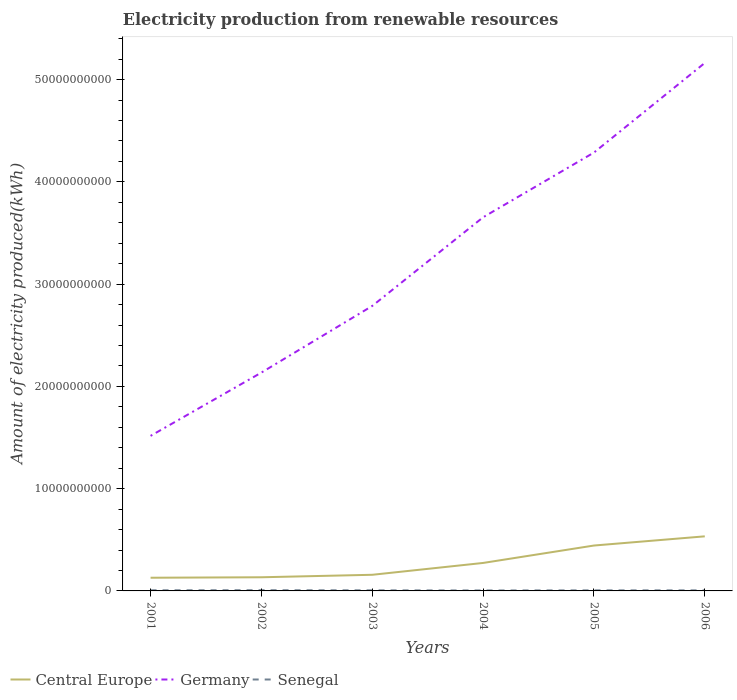Across all years, what is the maximum amount of electricity produced in Central Europe?
Keep it short and to the point. 1.29e+09. What is the difference between the highest and the second highest amount of electricity produced in Senegal?
Your answer should be very brief. 2.50e+07. What is the difference between the highest and the lowest amount of electricity produced in Senegal?
Provide a short and direct response. 2. What is the difference between two consecutive major ticks on the Y-axis?
Provide a succinct answer. 1.00e+1. Are the values on the major ticks of Y-axis written in scientific E-notation?
Offer a terse response. No. Does the graph contain any zero values?
Your response must be concise. No. Does the graph contain grids?
Provide a short and direct response. No. How many legend labels are there?
Your response must be concise. 3. What is the title of the graph?
Give a very brief answer. Electricity production from renewable resources. What is the label or title of the X-axis?
Give a very brief answer. Years. What is the label or title of the Y-axis?
Ensure brevity in your answer.  Amount of electricity produced(kWh). What is the Amount of electricity produced(kWh) of Central Europe in 2001?
Give a very brief answer. 1.29e+09. What is the Amount of electricity produced(kWh) of Germany in 2001?
Make the answer very short. 1.52e+1. What is the Amount of electricity produced(kWh) in Senegal in 2001?
Offer a terse response. 6.20e+07. What is the Amount of electricity produced(kWh) in Central Europe in 2002?
Your answer should be compact. 1.34e+09. What is the Amount of electricity produced(kWh) in Germany in 2002?
Your answer should be very brief. 2.14e+1. What is the Amount of electricity produced(kWh) of Senegal in 2002?
Give a very brief answer. 7.00e+07. What is the Amount of electricity produced(kWh) in Central Europe in 2003?
Your answer should be compact. 1.58e+09. What is the Amount of electricity produced(kWh) of Germany in 2003?
Your answer should be compact. 2.79e+1. What is the Amount of electricity produced(kWh) in Senegal in 2003?
Ensure brevity in your answer.  5.70e+07. What is the Amount of electricity produced(kWh) of Central Europe in 2004?
Give a very brief answer. 2.74e+09. What is the Amount of electricity produced(kWh) in Germany in 2004?
Make the answer very short. 3.65e+1. What is the Amount of electricity produced(kWh) of Senegal in 2004?
Offer a terse response. 4.50e+07. What is the Amount of electricity produced(kWh) of Central Europe in 2005?
Give a very brief answer. 4.44e+09. What is the Amount of electricity produced(kWh) in Germany in 2005?
Offer a very short reply. 4.29e+1. What is the Amount of electricity produced(kWh) in Senegal in 2005?
Provide a short and direct response. 5.50e+07. What is the Amount of electricity produced(kWh) of Central Europe in 2006?
Offer a terse response. 5.34e+09. What is the Amount of electricity produced(kWh) of Germany in 2006?
Offer a terse response. 5.16e+1. What is the Amount of electricity produced(kWh) of Senegal in 2006?
Keep it short and to the point. 5.50e+07. Across all years, what is the maximum Amount of electricity produced(kWh) of Central Europe?
Offer a very short reply. 5.34e+09. Across all years, what is the maximum Amount of electricity produced(kWh) of Germany?
Your answer should be compact. 5.16e+1. Across all years, what is the maximum Amount of electricity produced(kWh) of Senegal?
Your answer should be compact. 7.00e+07. Across all years, what is the minimum Amount of electricity produced(kWh) in Central Europe?
Give a very brief answer. 1.29e+09. Across all years, what is the minimum Amount of electricity produced(kWh) in Germany?
Your answer should be very brief. 1.52e+1. Across all years, what is the minimum Amount of electricity produced(kWh) in Senegal?
Ensure brevity in your answer.  4.50e+07. What is the total Amount of electricity produced(kWh) of Central Europe in the graph?
Your response must be concise. 1.67e+1. What is the total Amount of electricity produced(kWh) in Germany in the graph?
Your response must be concise. 1.95e+11. What is the total Amount of electricity produced(kWh) of Senegal in the graph?
Your answer should be very brief. 3.44e+08. What is the difference between the Amount of electricity produced(kWh) in Central Europe in 2001 and that in 2002?
Make the answer very short. -4.50e+07. What is the difference between the Amount of electricity produced(kWh) in Germany in 2001 and that in 2002?
Your answer should be compact. -6.19e+09. What is the difference between the Amount of electricity produced(kWh) in Senegal in 2001 and that in 2002?
Offer a terse response. -8.00e+06. What is the difference between the Amount of electricity produced(kWh) of Central Europe in 2001 and that in 2003?
Offer a very short reply. -2.88e+08. What is the difference between the Amount of electricity produced(kWh) in Germany in 2001 and that in 2003?
Keep it short and to the point. -1.27e+1. What is the difference between the Amount of electricity produced(kWh) of Central Europe in 2001 and that in 2004?
Offer a terse response. -1.45e+09. What is the difference between the Amount of electricity produced(kWh) of Germany in 2001 and that in 2004?
Your answer should be compact. -2.14e+1. What is the difference between the Amount of electricity produced(kWh) of Senegal in 2001 and that in 2004?
Give a very brief answer. 1.70e+07. What is the difference between the Amount of electricity produced(kWh) of Central Europe in 2001 and that in 2005?
Make the answer very short. -3.15e+09. What is the difference between the Amount of electricity produced(kWh) in Germany in 2001 and that in 2005?
Give a very brief answer. -2.77e+1. What is the difference between the Amount of electricity produced(kWh) in Senegal in 2001 and that in 2005?
Make the answer very short. 7.00e+06. What is the difference between the Amount of electricity produced(kWh) in Central Europe in 2001 and that in 2006?
Offer a very short reply. -4.05e+09. What is the difference between the Amount of electricity produced(kWh) in Germany in 2001 and that in 2006?
Your response must be concise. -3.65e+1. What is the difference between the Amount of electricity produced(kWh) of Central Europe in 2002 and that in 2003?
Your response must be concise. -2.43e+08. What is the difference between the Amount of electricity produced(kWh) of Germany in 2002 and that in 2003?
Ensure brevity in your answer.  -6.52e+09. What is the difference between the Amount of electricity produced(kWh) of Senegal in 2002 and that in 2003?
Your answer should be very brief. 1.30e+07. What is the difference between the Amount of electricity produced(kWh) in Central Europe in 2002 and that in 2004?
Provide a short and direct response. -1.40e+09. What is the difference between the Amount of electricity produced(kWh) in Germany in 2002 and that in 2004?
Your answer should be compact. -1.52e+1. What is the difference between the Amount of electricity produced(kWh) in Senegal in 2002 and that in 2004?
Keep it short and to the point. 2.50e+07. What is the difference between the Amount of electricity produced(kWh) of Central Europe in 2002 and that in 2005?
Your answer should be very brief. -3.10e+09. What is the difference between the Amount of electricity produced(kWh) in Germany in 2002 and that in 2005?
Your answer should be very brief. -2.15e+1. What is the difference between the Amount of electricity produced(kWh) in Senegal in 2002 and that in 2005?
Keep it short and to the point. 1.50e+07. What is the difference between the Amount of electricity produced(kWh) of Central Europe in 2002 and that in 2006?
Ensure brevity in your answer.  -4.00e+09. What is the difference between the Amount of electricity produced(kWh) of Germany in 2002 and that in 2006?
Provide a succinct answer. -3.03e+1. What is the difference between the Amount of electricity produced(kWh) in Senegal in 2002 and that in 2006?
Give a very brief answer. 1.50e+07. What is the difference between the Amount of electricity produced(kWh) in Central Europe in 2003 and that in 2004?
Make the answer very short. -1.16e+09. What is the difference between the Amount of electricity produced(kWh) of Germany in 2003 and that in 2004?
Provide a short and direct response. -8.67e+09. What is the difference between the Amount of electricity produced(kWh) of Senegal in 2003 and that in 2004?
Keep it short and to the point. 1.20e+07. What is the difference between the Amount of electricity produced(kWh) of Central Europe in 2003 and that in 2005?
Your answer should be compact. -2.86e+09. What is the difference between the Amount of electricity produced(kWh) in Germany in 2003 and that in 2005?
Keep it short and to the point. -1.50e+1. What is the difference between the Amount of electricity produced(kWh) of Senegal in 2003 and that in 2005?
Offer a terse response. 2.00e+06. What is the difference between the Amount of electricity produced(kWh) in Central Europe in 2003 and that in 2006?
Your answer should be very brief. -3.76e+09. What is the difference between the Amount of electricity produced(kWh) in Germany in 2003 and that in 2006?
Provide a succinct answer. -2.38e+1. What is the difference between the Amount of electricity produced(kWh) of Senegal in 2003 and that in 2006?
Offer a very short reply. 2.00e+06. What is the difference between the Amount of electricity produced(kWh) in Central Europe in 2004 and that in 2005?
Your answer should be compact. -1.70e+09. What is the difference between the Amount of electricity produced(kWh) of Germany in 2004 and that in 2005?
Give a very brief answer. -6.33e+09. What is the difference between the Amount of electricity produced(kWh) of Senegal in 2004 and that in 2005?
Ensure brevity in your answer.  -1.00e+07. What is the difference between the Amount of electricity produced(kWh) in Central Europe in 2004 and that in 2006?
Your answer should be very brief. -2.60e+09. What is the difference between the Amount of electricity produced(kWh) in Germany in 2004 and that in 2006?
Your response must be concise. -1.51e+1. What is the difference between the Amount of electricity produced(kWh) of Senegal in 2004 and that in 2006?
Your answer should be very brief. -1.00e+07. What is the difference between the Amount of electricity produced(kWh) of Central Europe in 2005 and that in 2006?
Your answer should be very brief. -8.99e+08. What is the difference between the Amount of electricity produced(kWh) of Germany in 2005 and that in 2006?
Give a very brief answer. -8.76e+09. What is the difference between the Amount of electricity produced(kWh) in Central Europe in 2001 and the Amount of electricity produced(kWh) in Germany in 2002?
Provide a succinct answer. -2.01e+1. What is the difference between the Amount of electricity produced(kWh) in Central Europe in 2001 and the Amount of electricity produced(kWh) in Senegal in 2002?
Your answer should be compact. 1.22e+09. What is the difference between the Amount of electricity produced(kWh) of Germany in 2001 and the Amount of electricity produced(kWh) of Senegal in 2002?
Give a very brief answer. 1.51e+1. What is the difference between the Amount of electricity produced(kWh) of Central Europe in 2001 and the Amount of electricity produced(kWh) of Germany in 2003?
Your answer should be very brief. -2.66e+1. What is the difference between the Amount of electricity produced(kWh) in Central Europe in 2001 and the Amount of electricity produced(kWh) in Senegal in 2003?
Your answer should be very brief. 1.23e+09. What is the difference between the Amount of electricity produced(kWh) of Germany in 2001 and the Amount of electricity produced(kWh) of Senegal in 2003?
Offer a very short reply. 1.51e+1. What is the difference between the Amount of electricity produced(kWh) in Central Europe in 2001 and the Amount of electricity produced(kWh) in Germany in 2004?
Provide a short and direct response. -3.52e+1. What is the difference between the Amount of electricity produced(kWh) of Central Europe in 2001 and the Amount of electricity produced(kWh) of Senegal in 2004?
Your response must be concise. 1.24e+09. What is the difference between the Amount of electricity produced(kWh) of Germany in 2001 and the Amount of electricity produced(kWh) of Senegal in 2004?
Ensure brevity in your answer.  1.51e+1. What is the difference between the Amount of electricity produced(kWh) of Central Europe in 2001 and the Amount of electricity produced(kWh) of Germany in 2005?
Ensure brevity in your answer.  -4.16e+1. What is the difference between the Amount of electricity produced(kWh) of Central Europe in 2001 and the Amount of electricity produced(kWh) of Senegal in 2005?
Keep it short and to the point. 1.24e+09. What is the difference between the Amount of electricity produced(kWh) of Germany in 2001 and the Amount of electricity produced(kWh) of Senegal in 2005?
Your answer should be very brief. 1.51e+1. What is the difference between the Amount of electricity produced(kWh) of Central Europe in 2001 and the Amount of electricity produced(kWh) of Germany in 2006?
Keep it short and to the point. -5.03e+1. What is the difference between the Amount of electricity produced(kWh) in Central Europe in 2001 and the Amount of electricity produced(kWh) in Senegal in 2006?
Keep it short and to the point. 1.24e+09. What is the difference between the Amount of electricity produced(kWh) of Germany in 2001 and the Amount of electricity produced(kWh) of Senegal in 2006?
Offer a very short reply. 1.51e+1. What is the difference between the Amount of electricity produced(kWh) in Central Europe in 2002 and the Amount of electricity produced(kWh) in Germany in 2003?
Offer a very short reply. -2.65e+1. What is the difference between the Amount of electricity produced(kWh) of Central Europe in 2002 and the Amount of electricity produced(kWh) of Senegal in 2003?
Provide a short and direct response. 1.28e+09. What is the difference between the Amount of electricity produced(kWh) in Germany in 2002 and the Amount of electricity produced(kWh) in Senegal in 2003?
Keep it short and to the point. 2.13e+1. What is the difference between the Amount of electricity produced(kWh) of Central Europe in 2002 and the Amount of electricity produced(kWh) of Germany in 2004?
Your answer should be compact. -3.52e+1. What is the difference between the Amount of electricity produced(kWh) of Central Europe in 2002 and the Amount of electricity produced(kWh) of Senegal in 2004?
Provide a short and direct response. 1.29e+09. What is the difference between the Amount of electricity produced(kWh) of Germany in 2002 and the Amount of electricity produced(kWh) of Senegal in 2004?
Provide a short and direct response. 2.13e+1. What is the difference between the Amount of electricity produced(kWh) of Central Europe in 2002 and the Amount of electricity produced(kWh) of Germany in 2005?
Offer a terse response. -4.15e+1. What is the difference between the Amount of electricity produced(kWh) of Central Europe in 2002 and the Amount of electricity produced(kWh) of Senegal in 2005?
Make the answer very short. 1.28e+09. What is the difference between the Amount of electricity produced(kWh) of Germany in 2002 and the Amount of electricity produced(kWh) of Senegal in 2005?
Offer a very short reply. 2.13e+1. What is the difference between the Amount of electricity produced(kWh) of Central Europe in 2002 and the Amount of electricity produced(kWh) of Germany in 2006?
Keep it short and to the point. -5.03e+1. What is the difference between the Amount of electricity produced(kWh) of Central Europe in 2002 and the Amount of electricity produced(kWh) of Senegal in 2006?
Offer a very short reply. 1.28e+09. What is the difference between the Amount of electricity produced(kWh) in Germany in 2002 and the Amount of electricity produced(kWh) in Senegal in 2006?
Offer a very short reply. 2.13e+1. What is the difference between the Amount of electricity produced(kWh) in Central Europe in 2003 and the Amount of electricity produced(kWh) in Germany in 2004?
Make the answer very short. -3.50e+1. What is the difference between the Amount of electricity produced(kWh) in Central Europe in 2003 and the Amount of electricity produced(kWh) in Senegal in 2004?
Your answer should be very brief. 1.53e+09. What is the difference between the Amount of electricity produced(kWh) in Germany in 2003 and the Amount of electricity produced(kWh) in Senegal in 2004?
Keep it short and to the point. 2.78e+1. What is the difference between the Amount of electricity produced(kWh) in Central Europe in 2003 and the Amount of electricity produced(kWh) in Germany in 2005?
Offer a terse response. -4.13e+1. What is the difference between the Amount of electricity produced(kWh) of Central Europe in 2003 and the Amount of electricity produced(kWh) of Senegal in 2005?
Make the answer very short. 1.52e+09. What is the difference between the Amount of electricity produced(kWh) of Germany in 2003 and the Amount of electricity produced(kWh) of Senegal in 2005?
Give a very brief answer. 2.78e+1. What is the difference between the Amount of electricity produced(kWh) in Central Europe in 2003 and the Amount of electricity produced(kWh) in Germany in 2006?
Your answer should be very brief. -5.01e+1. What is the difference between the Amount of electricity produced(kWh) of Central Europe in 2003 and the Amount of electricity produced(kWh) of Senegal in 2006?
Give a very brief answer. 1.52e+09. What is the difference between the Amount of electricity produced(kWh) of Germany in 2003 and the Amount of electricity produced(kWh) of Senegal in 2006?
Give a very brief answer. 2.78e+1. What is the difference between the Amount of electricity produced(kWh) of Central Europe in 2004 and the Amount of electricity produced(kWh) of Germany in 2005?
Provide a short and direct response. -4.01e+1. What is the difference between the Amount of electricity produced(kWh) in Central Europe in 2004 and the Amount of electricity produced(kWh) in Senegal in 2005?
Your response must be concise. 2.68e+09. What is the difference between the Amount of electricity produced(kWh) of Germany in 2004 and the Amount of electricity produced(kWh) of Senegal in 2005?
Provide a succinct answer. 3.65e+1. What is the difference between the Amount of electricity produced(kWh) of Central Europe in 2004 and the Amount of electricity produced(kWh) of Germany in 2006?
Make the answer very short. -4.89e+1. What is the difference between the Amount of electricity produced(kWh) of Central Europe in 2004 and the Amount of electricity produced(kWh) of Senegal in 2006?
Your answer should be very brief. 2.68e+09. What is the difference between the Amount of electricity produced(kWh) of Germany in 2004 and the Amount of electricity produced(kWh) of Senegal in 2006?
Ensure brevity in your answer.  3.65e+1. What is the difference between the Amount of electricity produced(kWh) in Central Europe in 2005 and the Amount of electricity produced(kWh) in Germany in 2006?
Offer a very short reply. -4.72e+1. What is the difference between the Amount of electricity produced(kWh) in Central Europe in 2005 and the Amount of electricity produced(kWh) in Senegal in 2006?
Ensure brevity in your answer.  4.38e+09. What is the difference between the Amount of electricity produced(kWh) of Germany in 2005 and the Amount of electricity produced(kWh) of Senegal in 2006?
Offer a very short reply. 4.28e+1. What is the average Amount of electricity produced(kWh) in Central Europe per year?
Give a very brief answer. 2.79e+09. What is the average Amount of electricity produced(kWh) in Germany per year?
Offer a very short reply. 3.26e+1. What is the average Amount of electricity produced(kWh) in Senegal per year?
Keep it short and to the point. 5.73e+07. In the year 2001, what is the difference between the Amount of electricity produced(kWh) in Central Europe and Amount of electricity produced(kWh) in Germany?
Your answer should be very brief. -1.39e+1. In the year 2001, what is the difference between the Amount of electricity produced(kWh) in Central Europe and Amount of electricity produced(kWh) in Senegal?
Offer a very short reply. 1.23e+09. In the year 2001, what is the difference between the Amount of electricity produced(kWh) in Germany and Amount of electricity produced(kWh) in Senegal?
Provide a short and direct response. 1.51e+1. In the year 2002, what is the difference between the Amount of electricity produced(kWh) of Central Europe and Amount of electricity produced(kWh) of Germany?
Give a very brief answer. -2.00e+1. In the year 2002, what is the difference between the Amount of electricity produced(kWh) in Central Europe and Amount of electricity produced(kWh) in Senegal?
Keep it short and to the point. 1.26e+09. In the year 2002, what is the difference between the Amount of electricity produced(kWh) of Germany and Amount of electricity produced(kWh) of Senegal?
Offer a very short reply. 2.13e+1. In the year 2003, what is the difference between the Amount of electricity produced(kWh) in Central Europe and Amount of electricity produced(kWh) in Germany?
Provide a succinct answer. -2.63e+1. In the year 2003, what is the difference between the Amount of electricity produced(kWh) of Central Europe and Amount of electricity produced(kWh) of Senegal?
Ensure brevity in your answer.  1.52e+09. In the year 2003, what is the difference between the Amount of electricity produced(kWh) of Germany and Amount of electricity produced(kWh) of Senegal?
Give a very brief answer. 2.78e+1. In the year 2004, what is the difference between the Amount of electricity produced(kWh) of Central Europe and Amount of electricity produced(kWh) of Germany?
Ensure brevity in your answer.  -3.38e+1. In the year 2004, what is the difference between the Amount of electricity produced(kWh) in Central Europe and Amount of electricity produced(kWh) in Senegal?
Your answer should be compact. 2.69e+09. In the year 2004, what is the difference between the Amount of electricity produced(kWh) of Germany and Amount of electricity produced(kWh) of Senegal?
Make the answer very short. 3.65e+1. In the year 2005, what is the difference between the Amount of electricity produced(kWh) of Central Europe and Amount of electricity produced(kWh) of Germany?
Your response must be concise. -3.84e+1. In the year 2005, what is the difference between the Amount of electricity produced(kWh) in Central Europe and Amount of electricity produced(kWh) in Senegal?
Your answer should be very brief. 4.38e+09. In the year 2005, what is the difference between the Amount of electricity produced(kWh) of Germany and Amount of electricity produced(kWh) of Senegal?
Your answer should be compact. 4.28e+1. In the year 2006, what is the difference between the Amount of electricity produced(kWh) in Central Europe and Amount of electricity produced(kWh) in Germany?
Your answer should be very brief. -4.63e+1. In the year 2006, what is the difference between the Amount of electricity produced(kWh) of Central Europe and Amount of electricity produced(kWh) of Senegal?
Ensure brevity in your answer.  5.28e+09. In the year 2006, what is the difference between the Amount of electricity produced(kWh) in Germany and Amount of electricity produced(kWh) in Senegal?
Give a very brief answer. 5.16e+1. What is the ratio of the Amount of electricity produced(kWh) in Central Europe in 2001 to that in 2002?
Provide a short and direct response. 0.97. What is the ratio of the Amount of electricity produced(kWh) in Germany in 2001 to that in 2002?
Your response must be concise. 0.71. What is the ratio of the Amount of electricity produced(kWh) in Senegal in 2001 to that in 2002?
Give a very brief answer. 0.89. What is the ratio of the Amount of electricity produced(kWh) in Central Europe in 2001 to that in 2003?
Offer a very short reply. 0.82. What is the ratio of the Amount of electricity produced(kWh) in Germany in 2001 to that in 2003?
Ensure brevity in your answer.  0.54. What is the ratio of the Amount of electricity produced(kWh) in Senegal in 2001 to that in 2003?
Your response must be concise. 1.09. What is the ratio of the Amount of electricity produced(kWh) in Central Europe in 2001 to that in 2004?
Your response must be concise. 0.47. What is the ratio of the Amount of electricity produced(kWh) of Germany in 2001 to that in 2004?
Keep it short and to the point. 0.41. What is the ratio of the Amount of electricity produced(kWh) of Senegal in 2001 to that in 2004?
Your response must be concise. 1.38. What is the ratio of the Amount of electricity produced(kWh) of Central Europe in 2001 to that in 2005?
Provide a succinct answer. 0.29. What is the ratio of the Amount of electricity produced(kWh) in Germany in 2001 to that in 2005?
Make the answer very short. 0.35. What is the ratio of the Amount of electricity produced(kWh) of Senegal in 2001 to that in 2005?
Give a very brief answer. 1.13. What is the ratio of the Amount of electricity produced(kWh) in Central Europe in 2001 to that in 2006?
Give a very brief answer. 0.24. What is the ratio of the Amount of electricity produced(kWh) of Germany in 2001 to that in 2006?
Ensure brevity in your answer.  0.29. What is the ratio of the Amount of electricity produced(kWh) of Senegal in 2001 to that in 2006?
Offer a terse response. 1.13. What is the ratio of the Amount of electricity produced(kWh) in Central Europe in 2002 to that in 2003?
Make the answer very short. 0.85. What is the ratio of the Amount of electricity produced(kWh) of Germany in 2002 to that in 2003?
Provide a short and direct response. 0.77. What is the ratio of the Amount of electricity produced(kWh) of Senegal in 2002 to that in 2003?
Your answer should be very brief. 1.23. What is the ratio of the Amount of electricity produced(kWh) of Central Europe in 2002 to that in 2004?
Give a very brief answer. 0.49. What is the ratio of the Amount of electricity produced(kWh) of Germany in 2002 to that in 2004?
Offer a very short reply. 0.58. What is the ratio of the Amount of electricity produced(kWh) in Senegal in 2002 to that in 2004?
Provide a short and direct response. 1.56. What is the ratio of the Amount of electricity produced(kWh) in Central Europe in 2002 to that in 2005?
Offer a very short reply. 0.3. What is the ratio of the Amount of electricity produced(kWh) in Germany in 2002 to that in 2005?
Ensure brevity in your answer.  0.5. What is the ratio of the Amount of electricity produced(kWh) in Senegal in 2002 to that in 2005?
Offer a very short reply. 1.27. What is the ratio of the Amount of electricity produced(kWh) of Central Europe in 2002 to that in 2006?
Your answer should be compact. 0.25. What is the ratio of the Amount of electricity produced(kWh) in Germany in 2002 to that in 2006?
Provide a short and direct response. 0.41. What is the ratio of the Amount of electricity produced(kWh) of Senegal in 2002 to that in 2006?
Your answer should be compact. 1.27. What is the ratio of the Amount of electricity produced(kWh) in Central Europe in 2003 to that in 2004?
Give a very brief answer. 0.58. What is the ratio of the Amount of electricity produced(kWh) in Germany in 2003 to that in 2004?
Provide a succinct answer. 0.76. What is the ratio of the Amount of electricity produced(kWh) of Senegal in 2003 to that in 2004?
Provide a succinct answer. 1.27. What is the ratio of the Amount of electricity produced(kWh) of Central Europe in 2003 to that in 2005?
Your answer should be compact. 0.36. What is the ratio of the Amount of electricity produced(kWh) of Germany in 2003 to that in 2005?
Your answer should be compact. 0.65. What is the ratio of the Amount of electricity produced(kWh) of Senegal in 2003 to that in 2005?
Your answer should be very brief. 1.04. What is the ratio of the Amount of electricity produced(kWh) in Central Europe in 2003 to that in 2006?
Give a very brief answer. 0.3. What is the ratio of the Amount of electricity produced(kWh) in Germany in 2003 to that in 2006?
Your response must be concise. 0.54. What is the ratio of the Amount of electricity produced(kWh) of Senegal in 2003 to that in 2006?
Provide a succinct answer. 1.04. What is the ratio of the Amount of electricity produced(kWh) of Central Europe in 2004 to that in 2005?
Your answer should be compact. 0.62. What is the ratio of the Amount of electricity produced(kWh) in Germany in 2004 to that in 2005?
Your answer should be compact. 0.85. What is the ratio of the Amount of electricity produced(kWh) of Senegal in 2004 to that in 2005?
Make the answer very short. 0.82. What is the ratio of the Amount of electricity produced(kWh) in Central Europe in 2004 to that in 2006?
Your answer should be very brief. 0.51. What is the ratio of the Amount of electricity produced(kWh) in Germany in 2004 to that in 2006?
Offer a very short reply. 0.71. What is the ratio of the Amount of electricity produced(kWh) of Senegal in 2004 to that in 2006?
Offer a very short reply. 0.82. What is the ratio of the Amount of electricity produced(kWh) of Central Europe in 2005 to that in 2006?
Provide a succinct answer. 0.83. What is the ratio of the Amount of electricity produced(kWh) in Germany in 2005 to that in 2006?
Offer a terse response. 0.83. What is the difference between the highest and the second highest Amount of electricity produced(kWh) of Central Europe?
Provide a short and direct response. 8.99e+08. What is the difference between the highest and the second highest Amount of electricity produced(kWh) of Germany?
Offer a very short reply. 8.76e+09. What is the difference between the highest and the second highest Amount of electricity produced(kWh) in Senegal?
Provide a short and direct response. 8.00e+06. What is the difference between the highest and the lowest Amount of electricity produced(kWh) in Central Europe?
Ensure brevity in your answer.  4.05e+09. What is the difference between the highest and the lowest Amount of electricity produced(kWh) of Germany?
Provide a short and direct response. 3.65e+1. What is the difference between the highest and the lowest Amount of electricity produced(kWh) of Senegal?
Your answer should be compact. 2.50e+07. 